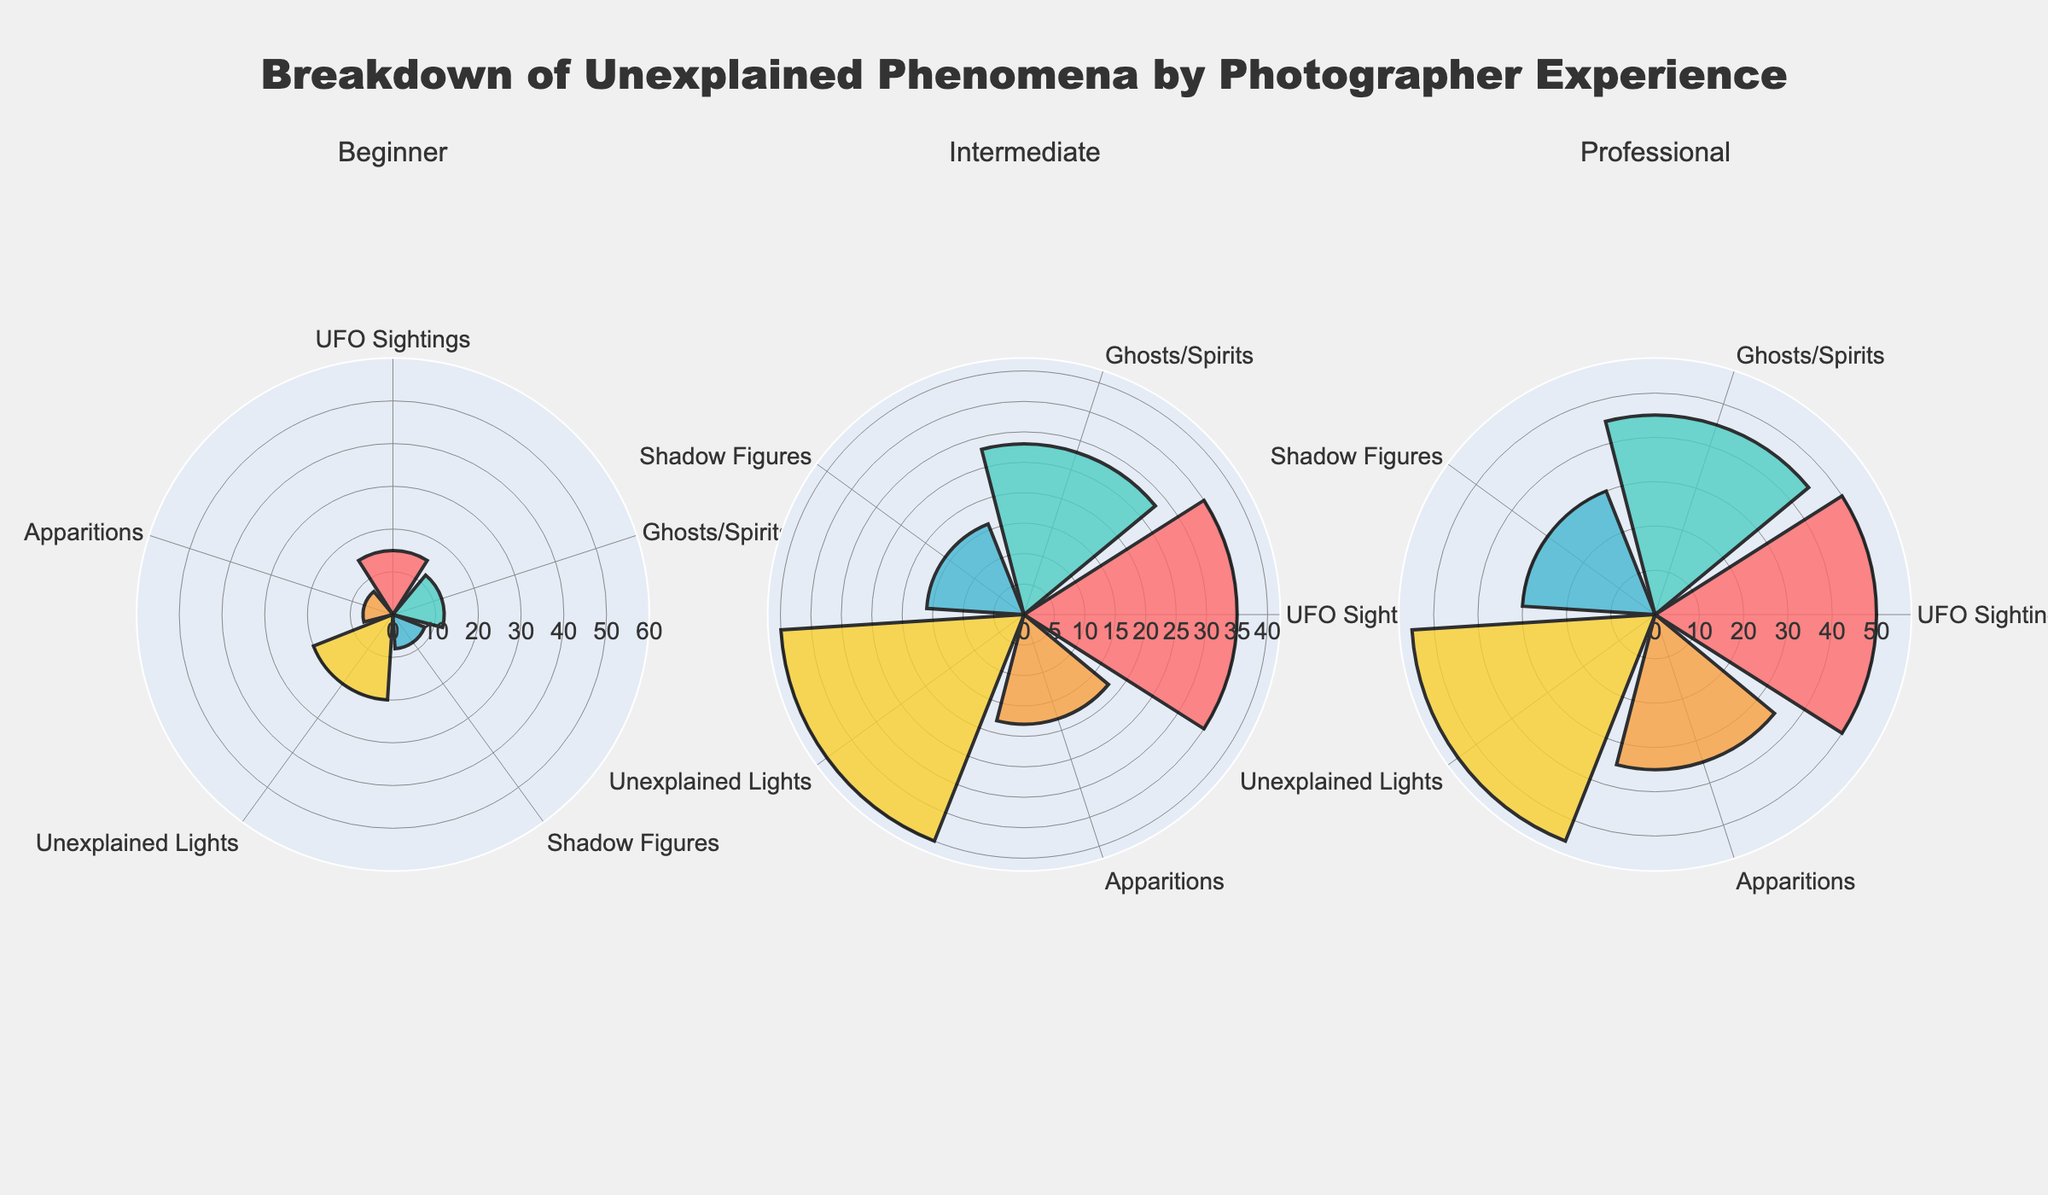What's the title of the figure? The title of the figure is usually found at the top of the plot and summarizes the main topic of the figure. In this case, it states the specific focus on the breakdown of unexplained phenomena by experience level.
Answer: Breakdown of Unexplained Phenomena by Photographer Experience How many phenomenon types are documented by professionals? To find this, look at the subplot labeled "Professional" and count the different phenomenon types listed along the circular axis.
Answer: 5 Which experience level reports the highest number of UFO sightings? Compare the "UFO Sightings" bars in each subplot. The highest bar represents the highest count.
Answer: Professional Which phenomenon type is documented the least by beginners? In the subplot for "Beginner," find the bar with the smallest value.
Answer: Apparitions What is the range of counts for the radial axis in the subplots? The radial axis shows the range of counts for the data points. This range is consistent across all subplots.
Answer: 0 to 60 How does the number of UFO sightings differ between beginners and professionals? Look at both the "Beginner" and "Professional" subplots, comparing the height of the bars for "UFO Sightings." Subtract the beginner value from the professional value.
Answer: 35 What is the sum of documented unexplained lights by all experience levels? Add the counts of "Unexplained Lights" from the Beginner, Intermediate, and Professional subplots.
Answer: 115 Which phenomenon type sees the greatest increase in documentation from beginners to intermediates? Compare each phenomenon type between the beginner and intermediate subplots. The one with the highest difference indicates the greatest increase.
Answer: UFO Sightings Between which two phenomenon types do professionals report the closest counts? Look at the subplot for "Professional" and compare the counts for each phenomenon. Identify the two types with the smallest difference in their counts.
Answer: Ghosts/Spirits and Apparitions What is the average number of shadow figures documented across all experience levels? Sum the counts of "Shadow Figures" for Beginner, Intermediate, and Professional, then divide by the number of experience levels, which is 3.
Answer: 18 